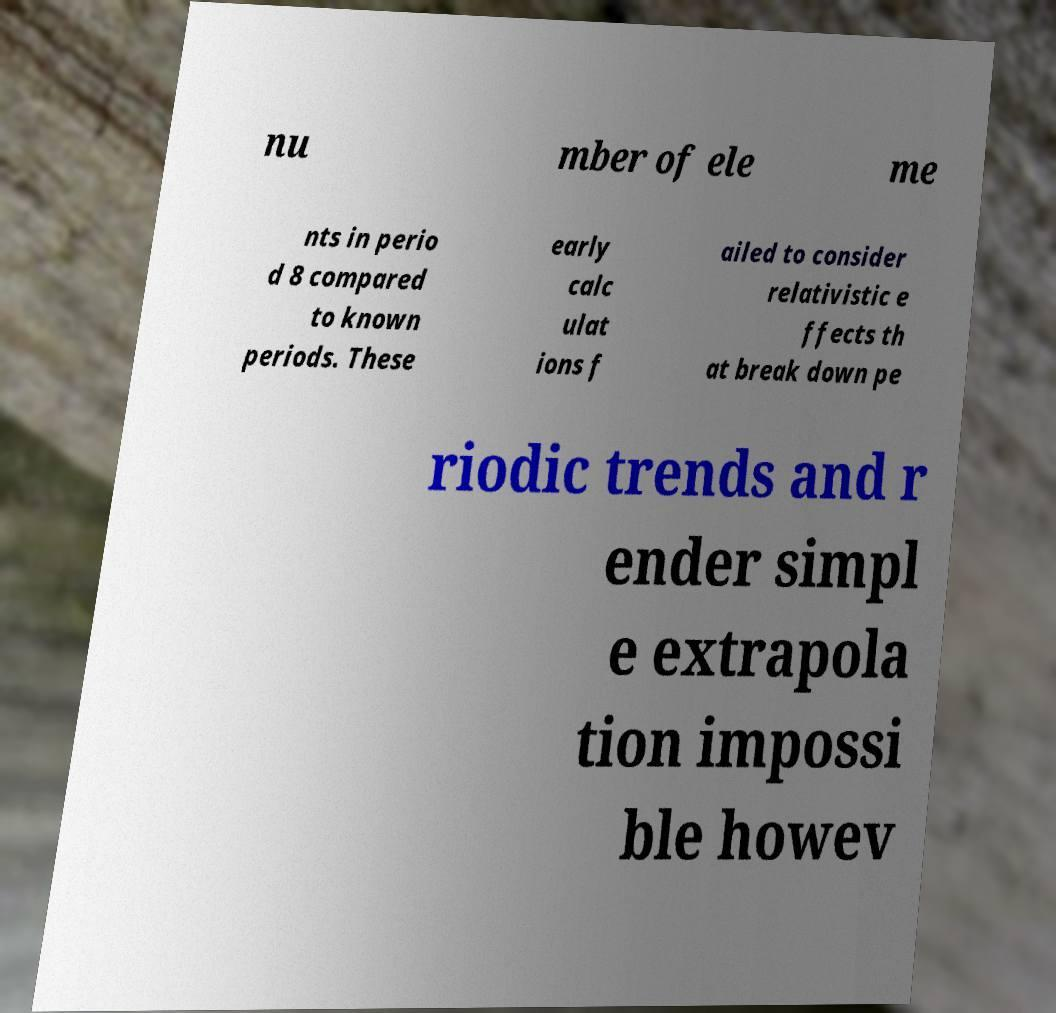There's text embedded in this image that I need extracted. Can you transcribe it verbatim? nu mber of ele me nts in perio d 8 compared to known periods. These early calc ulat ions f ailed to consider relativistic e ffects th at break down pe riodic trends and r ender simpl e extrapola tion impossi ble howev 